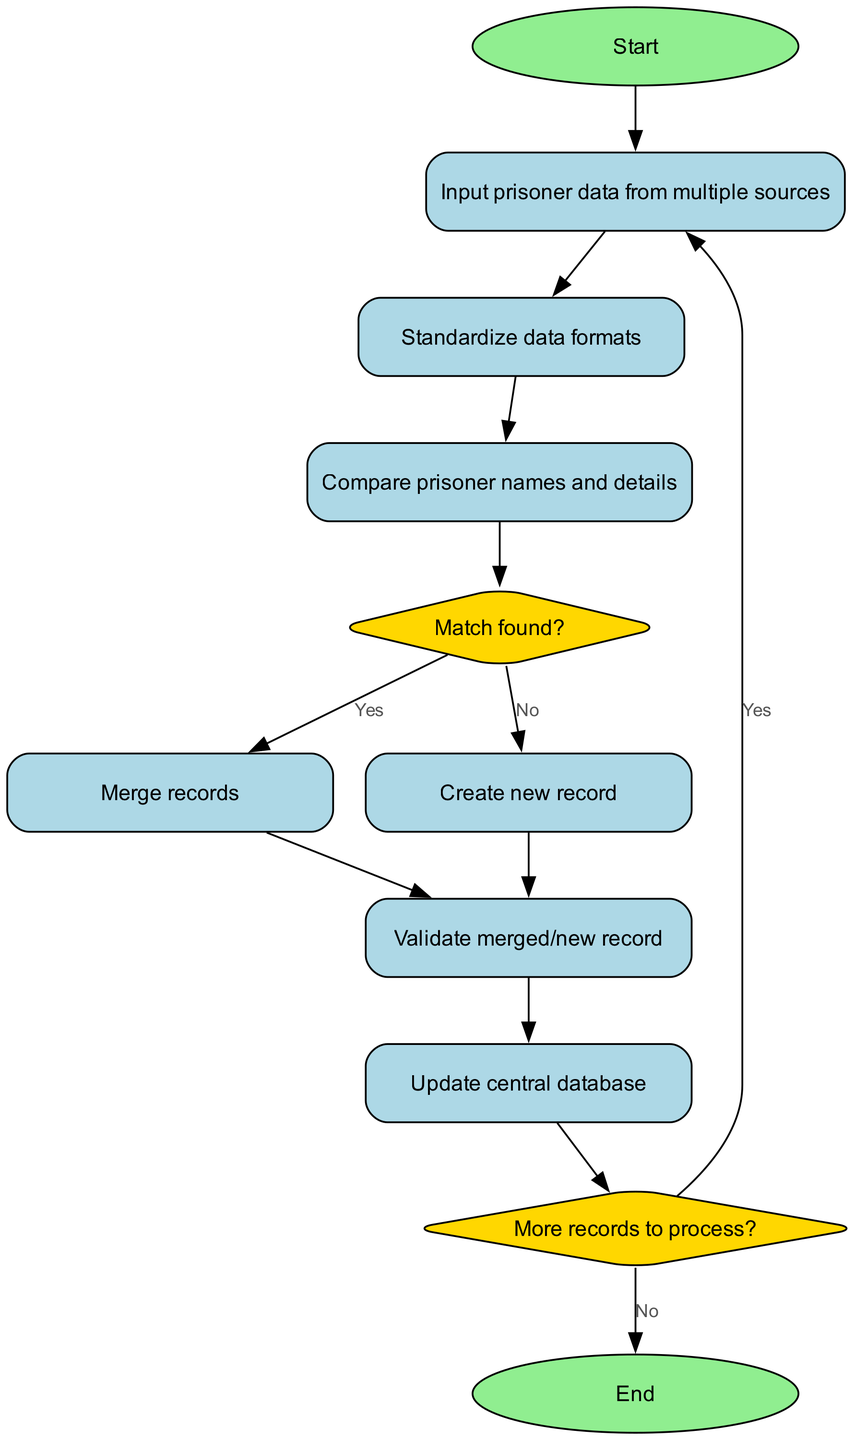What is the starting point of the algorithm? The starting point of the algorithm is defined in the 'start' node, which initiates the process.
Answer: Start How many nodes are present in the diagram? By counting the nodes listed in the diagram data, we find there are ten distinct nodes.
Answer: 10 What happens after the "Compare prisoner names and details"? Following the "Compare prisoner names and details", the flow leads to the "Match found?" decision node, which evaluates if a match exists.
Answer: Match found? What are the two possible outcomes from the "Match found?" decision? The two possible outcomes from the "Match found?" decision are 'Yes', leading to 'Merge records', and 'No', leading to 'Create new record'.
Answer: Yes, No What is the final node in the flowchart? The final node in the flowchart marks the end of the algorithm, indicated by the 'end' node, which concludes the processing of records.
Answer: End After creating a new record, what is the next step? After creating a new record, the next step is to validate the merged/new record, which ensures accuracy and correctness before further actions.
Answer: Validate merged/new record How does the algorithm handle more records after updating the database? After updating the central database, the algorithm checks if there are more records to process. If so, it returns to the 'Input prisoner data from multiple sources' node; otherwise, it ends the process.
Answer: More records to process? What type of node is used to indicate a decision in this flowchart? The decisions in the flowchart, such as whether a match is found, are indicated by diamond-shaped nodes, which are characteristic of decision points.
Answer: Diamond What condition leads to the creation of a new record? The creation of a new record occurs when the 'Match found?' decision yields a 'No', indicating that no existing match was found during comparison.
Answer: No What operation is performed after validating a record? After validating a record, the next operation is updating the central database, which ensures that the newly validated or merged record is incorporated into the system.
Answer: Update central database 